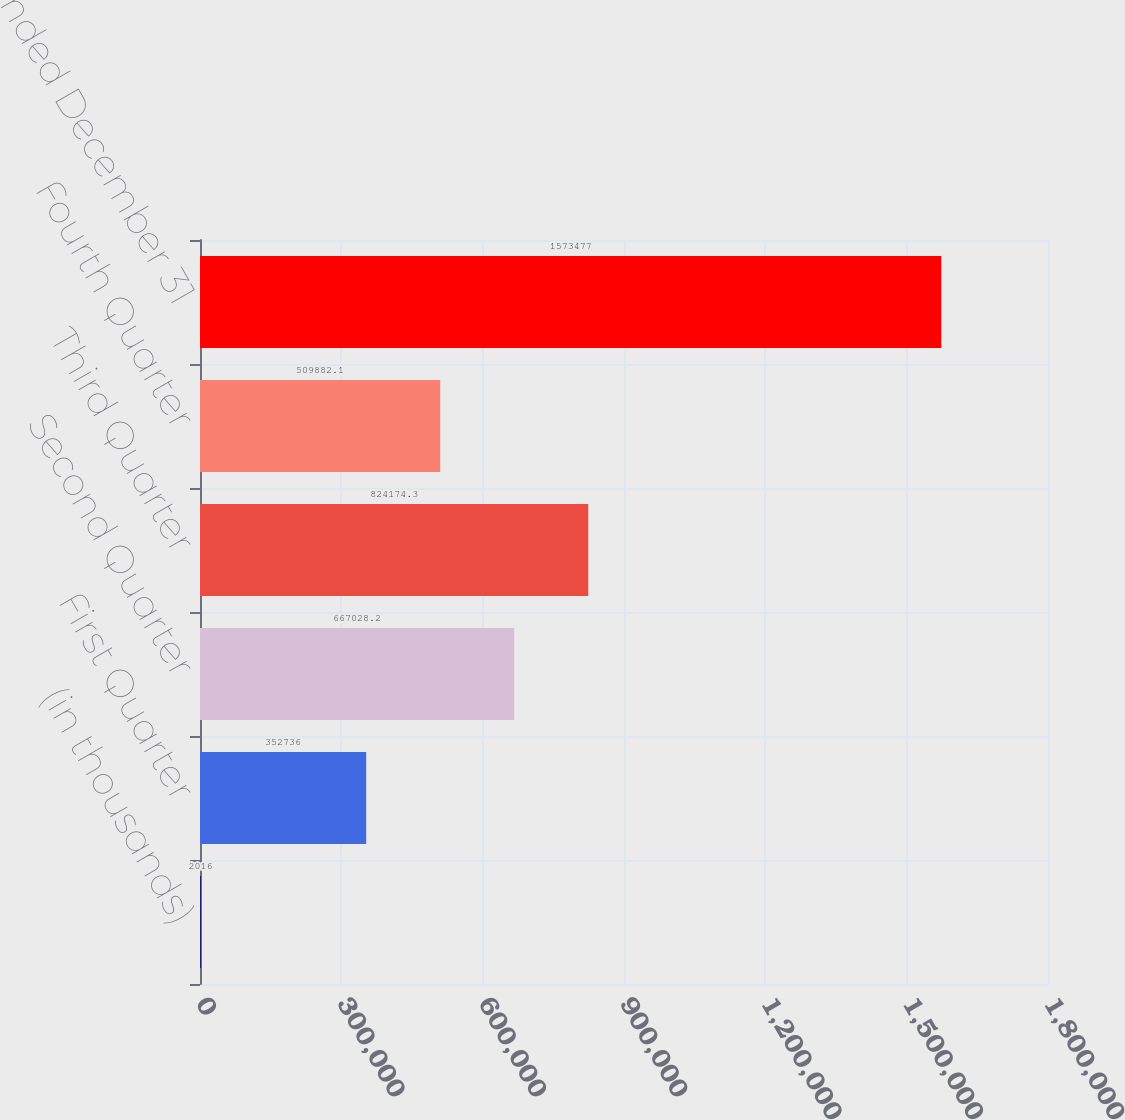Convert chart to OTSL. <chart><loc_0><loc_0><loc_500><loc_500><bar_chart><fcel>(in thousands)<fcel>First Quarter<fcel>Second Quarter<fcel>Third Quarter<fcel>Fourth Quarter<fcel>Years ended December 31<nl><fcel>2016<fcel>352736<fcel>667028<fcel>824174<fcel>509882<fcel>1.57348e+06<nl></chart> 